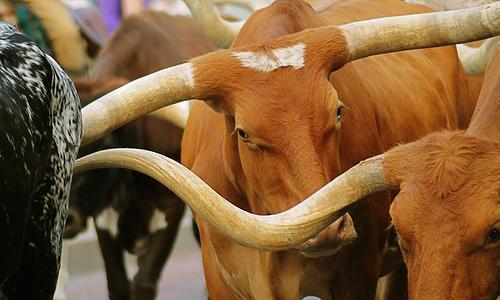How many cows are visible?
Give a very brief answer. 4. 